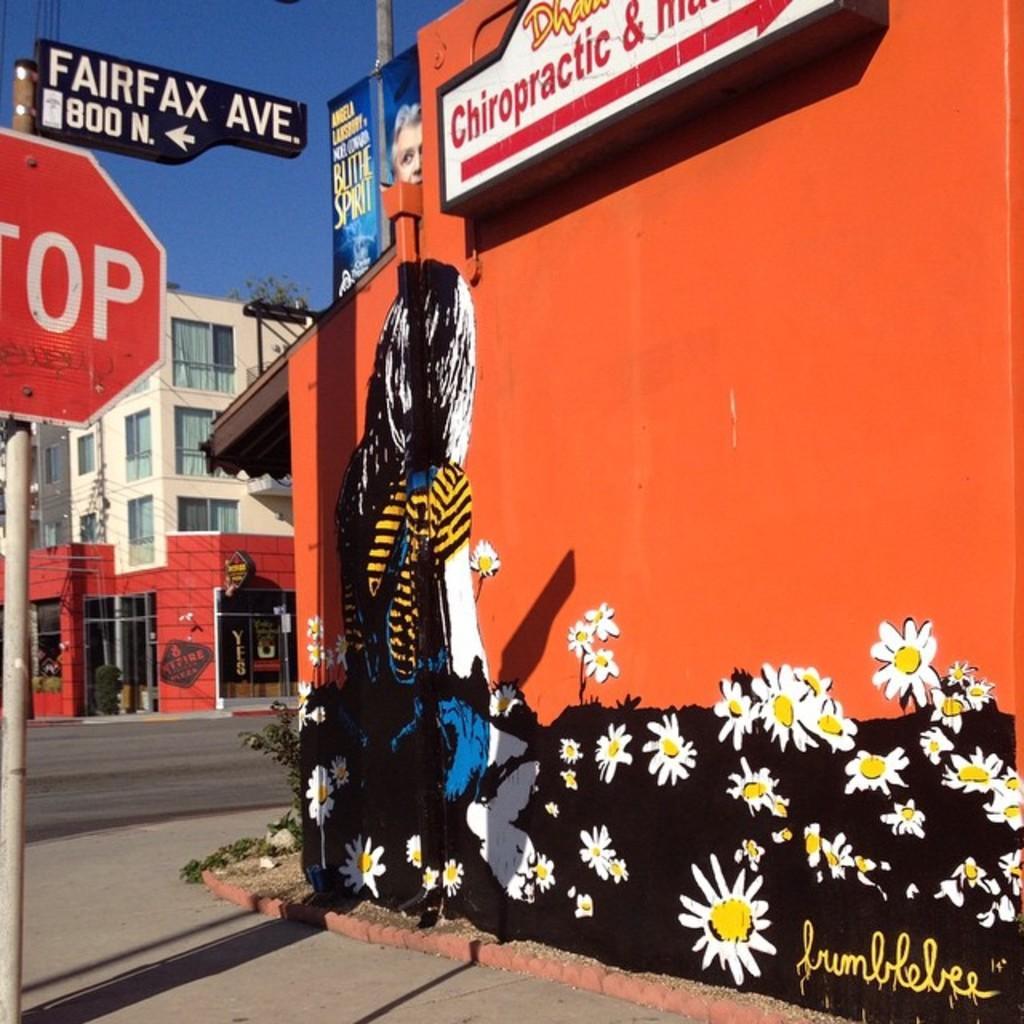How would you summarize this image in a sentence or two? In this image we can see a graffiti painting on the wall along with a sign board, beside the wall we can see a pole with sign boards, there we can also see few buildings, windows and plants. 